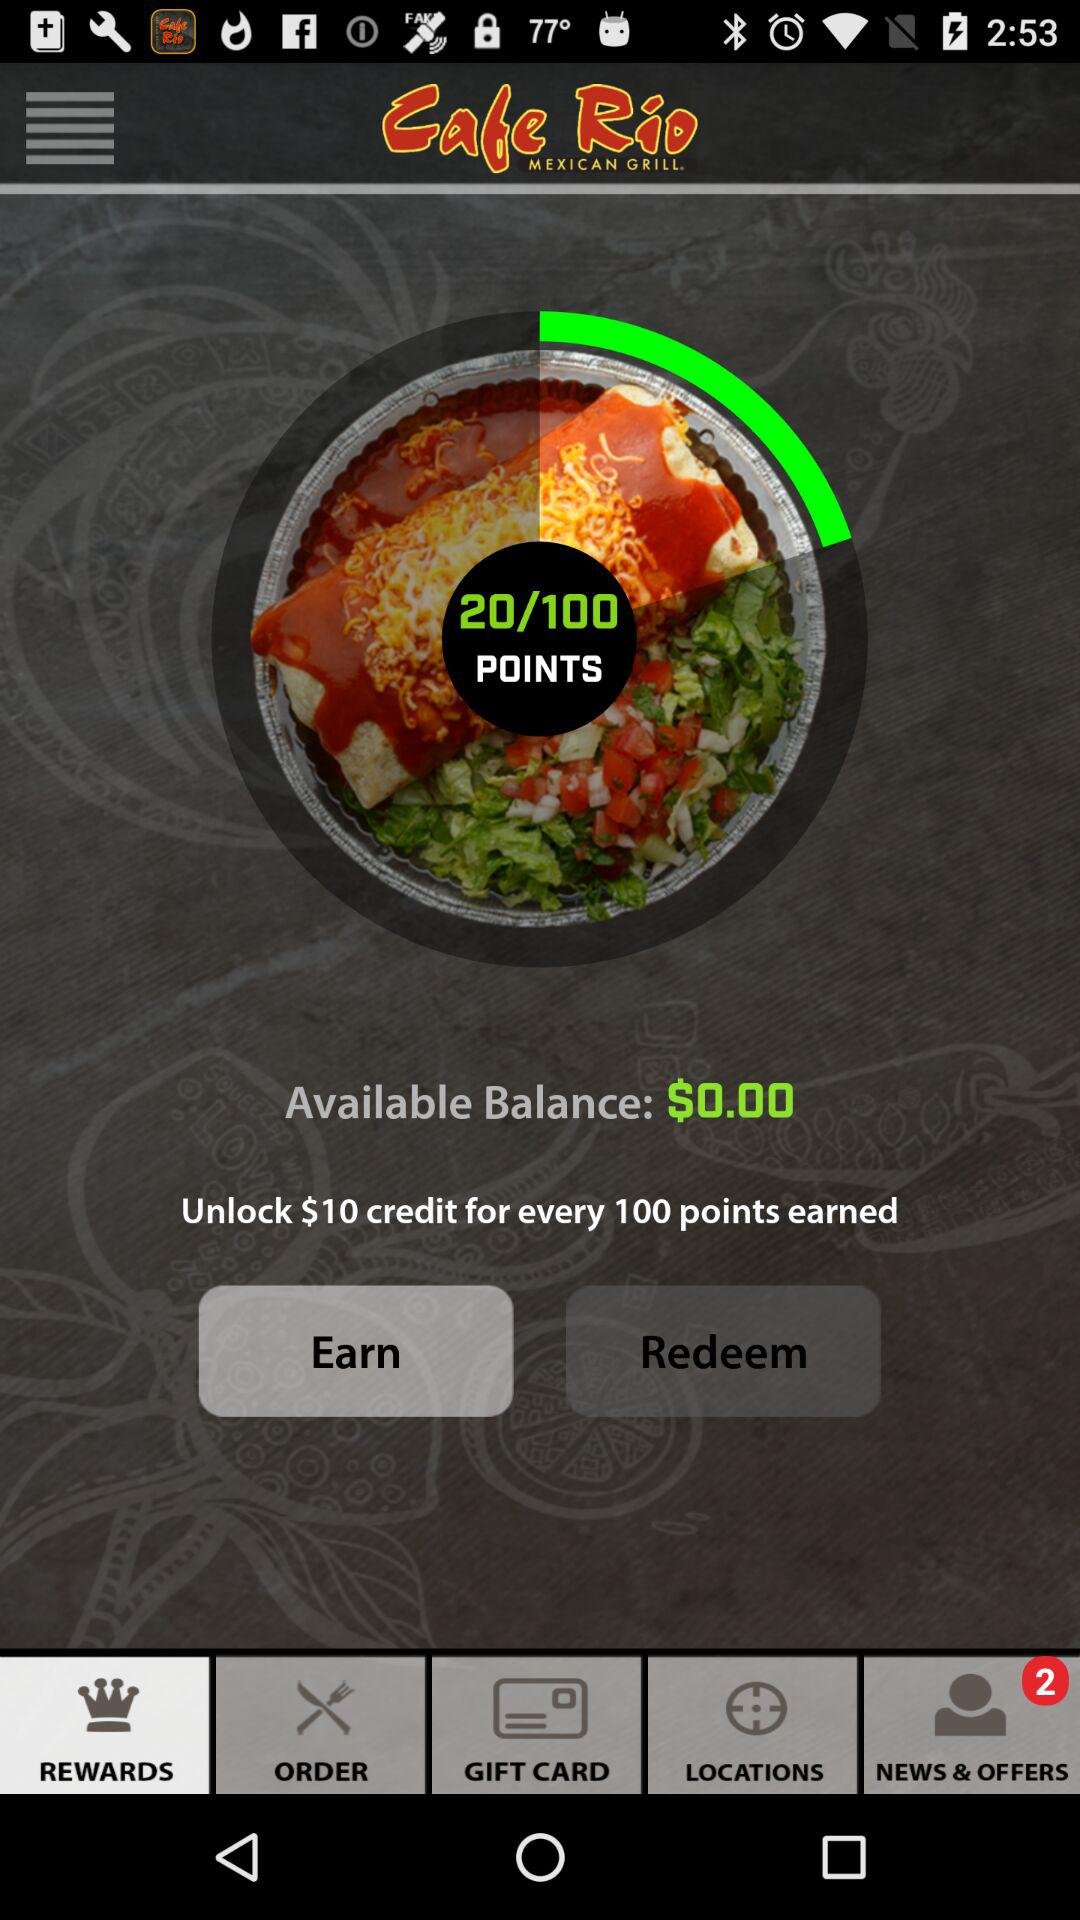What exactly can I do with the points I earn in this program? The points earned in this program can be redeemed for credit towards future purchases. For example, every 100 points can unlock a $10 credit that you may apply as a discount on orders. Can the points be used for anything else? Typically, rewards points are used to redeem credit, but some programs offer additional rewards such as exclusive offers, free items, or special discounts. Check the program's details or terms and conditions for further information on how points can be utilized. 